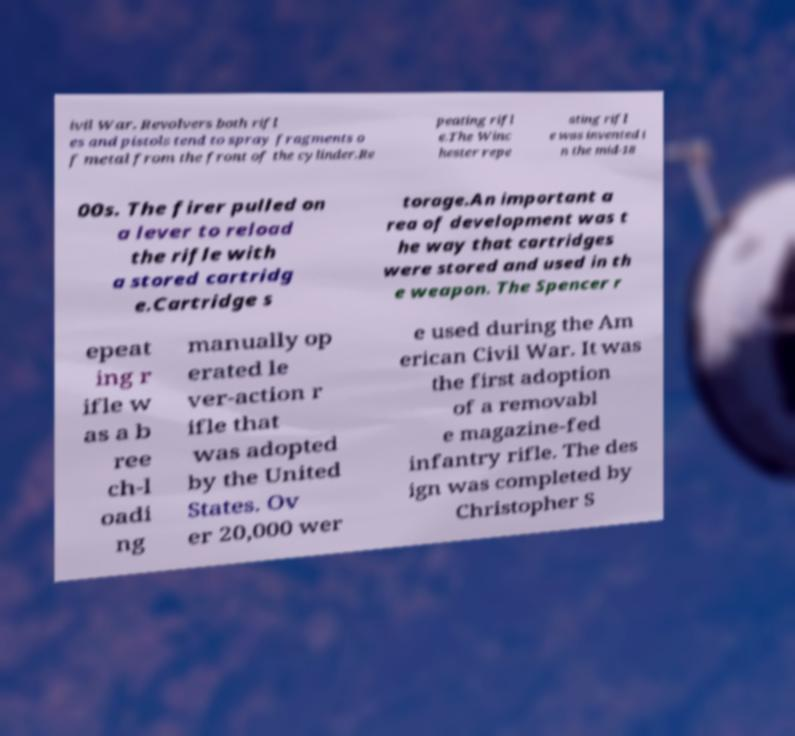For documentation purposes, I need the text within this image transcribed. Could you provide that? ivil War. Revolvers both rifl es and pistols tend to spray fragments o f metal from the front of the cylinder.Re peating rifl e.The Winc hester repe ating rifl e was invented i n the mid-18 00s. The firer pulled on a lever to reload the rifle with a stored cartridg e.Cartridge s torage.An important a rea of development was t he way that cartridges were stored and used in th e weapon. The Spencer r epeat ing r ifle w as a b ree ch-l oadi ng manually op erated le ver-action r ifle that was adopted by the United States. Ov er 20,000 wer e used during the Am erican Civil War. It was the first adoption of a removabl e magazine-fed infantry rifle. The des ign was completed by Christopher S 